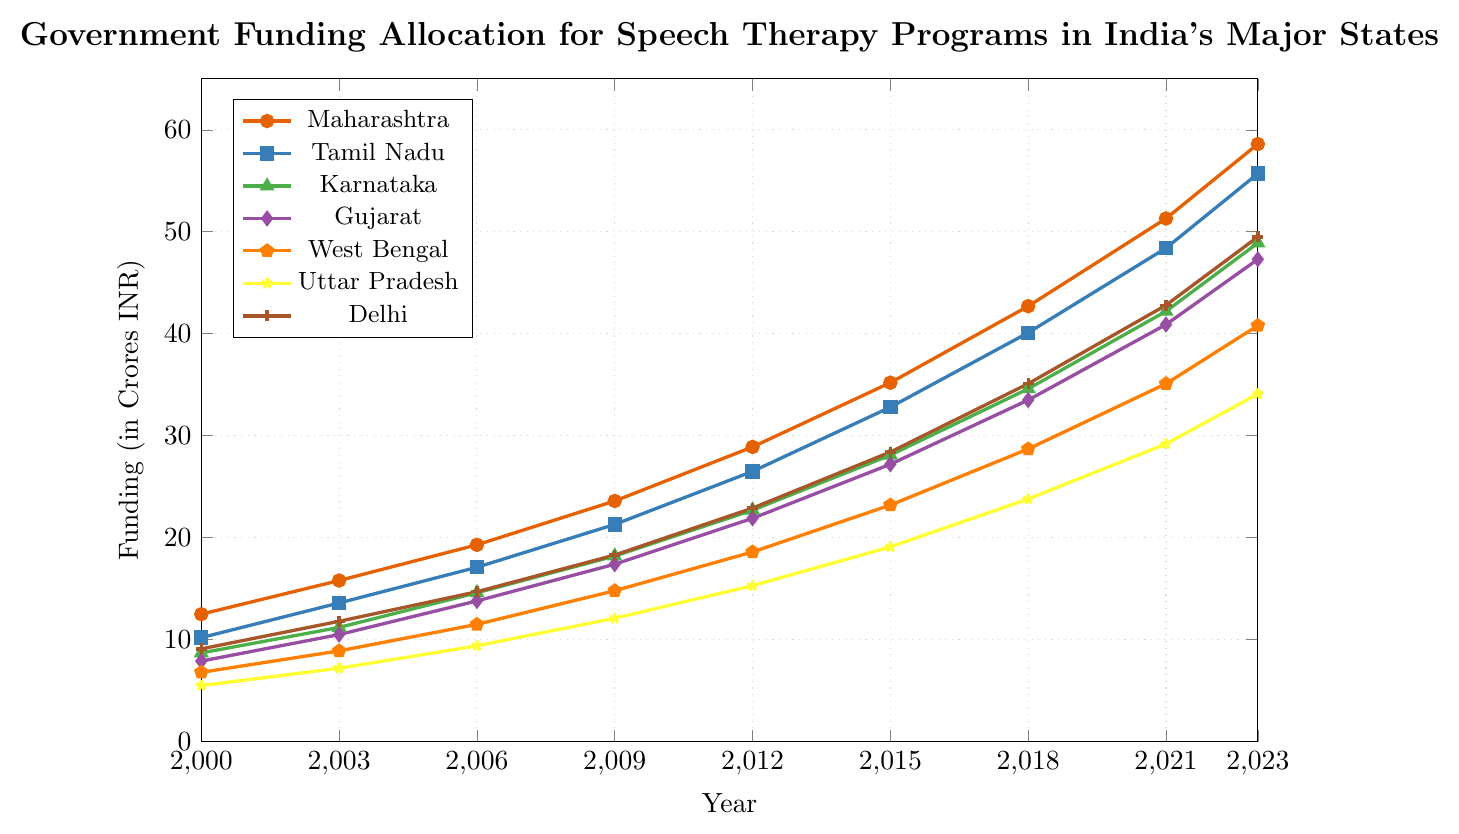What year did Maharashtra first surpass 50 crores in funding? The graph shows that Maharashtra's funding reaches just over 50 crores in 2021
Answer: 2021 Compare the funding for Karnataka and Uttar Pradesh in 2023. Which one is greater and by how much? In 2023, Karnataka has 48.9 crores and Uttar Pradesh has 34.1 crores. 48.9 - 34.1 = 14.8 crores
Answer: Karnataka, by 14.8 crores Which state had the lowest funding in 2000 and how much was it? The graph shows Uttar Pradesh had the lowest funding in 2000 with 5.5 crores
Answer: Uttar Pradesh, 5.5 crores How much did the funding for Tamil Nadu increase from 2006 to 2009? Tamil Nadu's funding was 17.1 crores in 2006 and 21.3 crores in 2009. 21.3 - 17.1 = 4.2 crores
Answer: 4.2 crores Which state had the highest funding in 2018, and what was the amount? The graph shows Maharashtra had the highest funding in 2018 at 42.7 crores
Answer: Maharashtra, 42.7 crores Calculate the average funding for Delhi over the years shown. Funding for Delhi: 9.1, 11.8, 14.7, 18.3, 22.9, 28.4, 35.1, 42.8, 49.5. Sum = 232.6. Average = 232.6 / 9 = 25.84 crores
Answer: 25.84 crores Compare the funding growth of West Bengal and Gujarat from 2000 to 2023. Which state had a higher increase? West Bengal grew from 6.8 to 40.8 crores (increase of 34 crores). Gujarat grew from 7.9 to 47.3 crores (increase of 39.4 crores). Gujarat had a higher increase
Answer: Gujarat What is the trend in funding for Uttar Pradesh over the years? The graph shows a consistent upward trend in funding for Uttar Pradesh from 5.5 crores in 2000 to 34.1 crores in 2023
Answer: Consistent upward trend Compare the funding for Maharashtra and West Bengal in 2015. Which state has more funding and by how much? In 2015, Maharashtra has 35.2 crores and West Bengal has 23.2 crores. 35.2 - 23.2 = 12 crores
Answer: Maharashtra, by 12 crores 